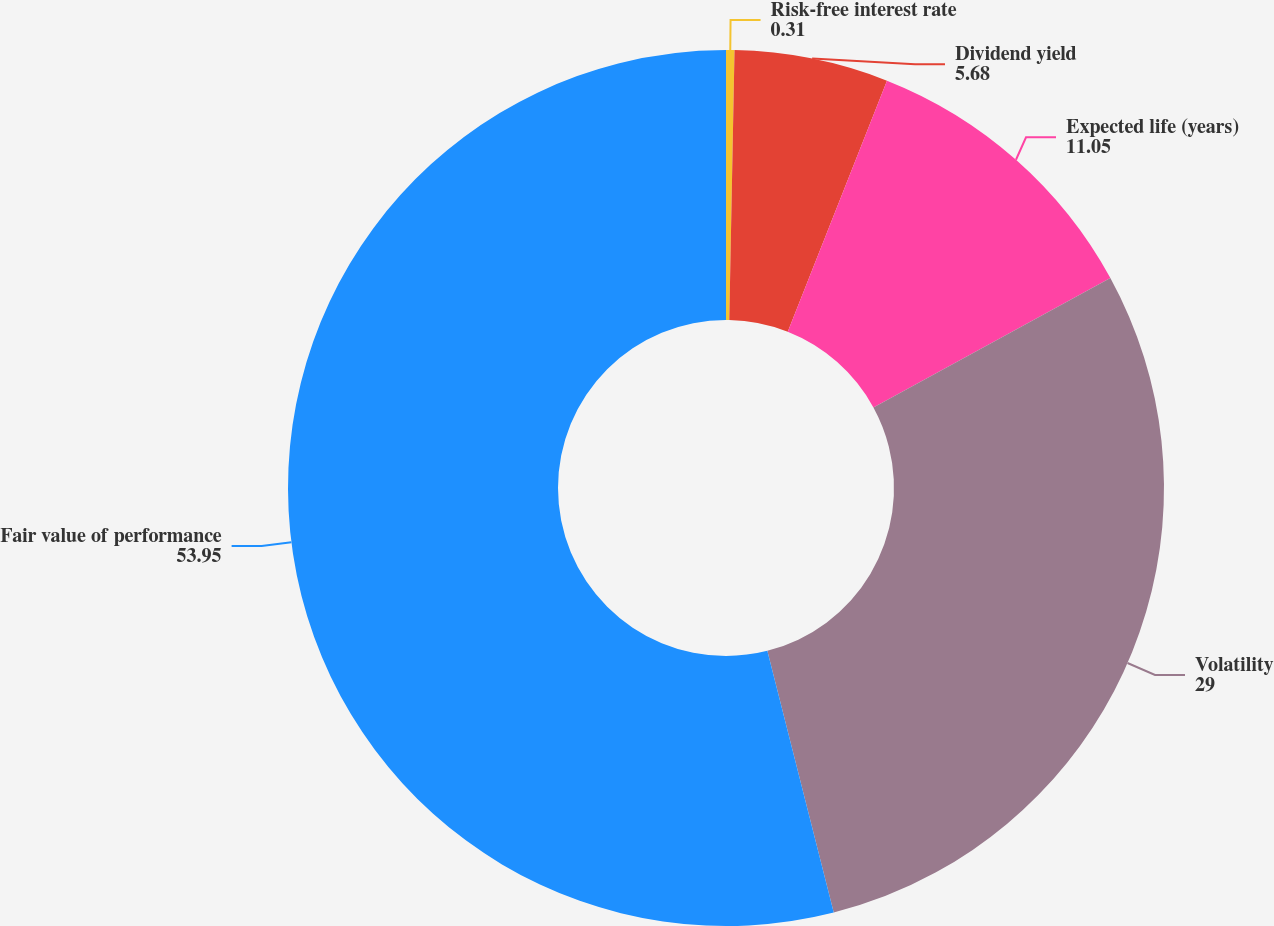<chart> <loc_0><loc_0><loc_500><loc_500><pie_chart><fcel>Risk-free interest rate<fcel>Dividend yield<fcel>Expected life (years)<fcel>Volatility<fcel>Fair value of performance<nl><fcel>0.31%<fcel>5.68%<fcel>11.05%<fcel>29.0%<fcel>53.95%<nl></chart> 